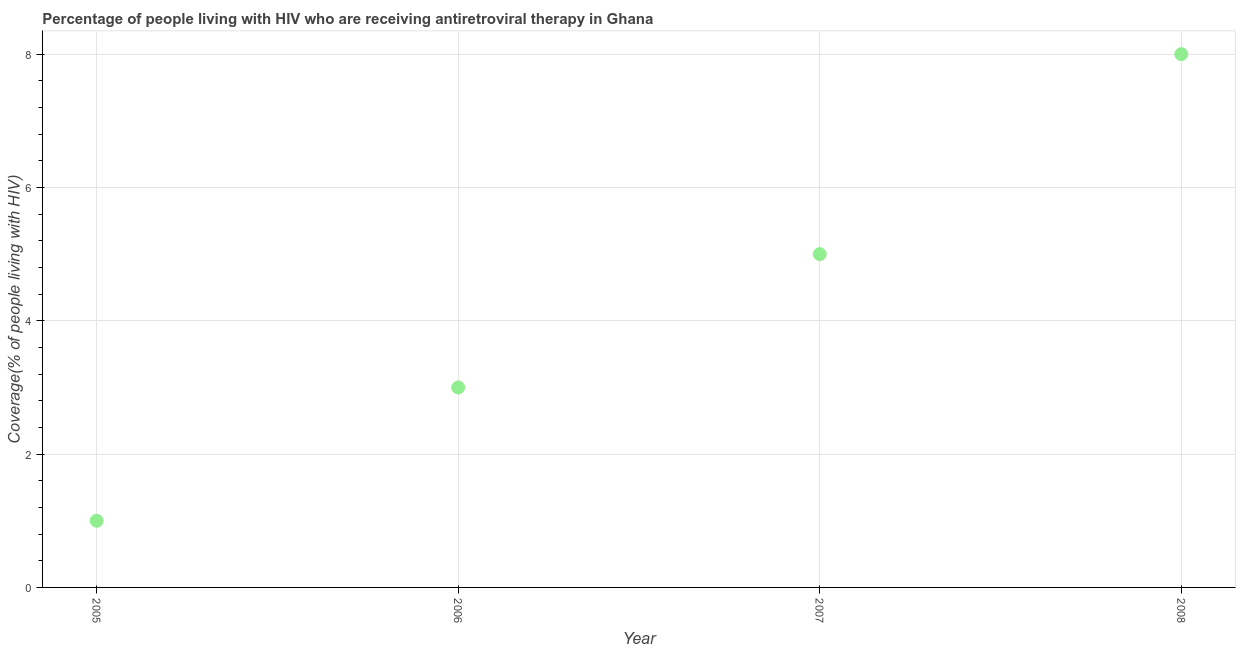What is the antiretroviral therapy coverage in 2007?
Offer a very short reply. 5. Across all years, what is the maximum antiretroviral therapy coverage?
Offer a very short reply. 8. Across all years, what is the minimum antiretroviral therapy coverage?
Your answer should be very brief. 1. In which year was the antiretroviral therapy coverage minimum?
Your response must be concise. 2005. What is the sum of the antiretroviral therapy coverage?
Offer a very short reply. 17. What is the difference between the antiretroviral therapy coverage in 2006 and 2007?
Your response must be concise. -2. What is the average antiretroviral therapy coverage per year?
Offer a very short reply. 4.25. In how many years, is the antiretroviral therapy coverage greater than 5.2 %?
Provide a succinct answer. 1. Is the difference between the antiretroviral therapy coverage in 2006 and 2007 greater than the difference between any two years?
Your answer should be very brief. No. Is the sum of the antiretroviral therapy coverage in 2005 and 2006 greater than the maximum antiretroviral therapy coverage across all years?
Give a very brief answer. No. What is the difference between the highest and the lowest antiretroviral therapy coverage?
Your answer should be very brief. 7. In how many years, is the antiretroviral therapy coverage greater than the average antiretroviral therapy coverage taken over all years?
Offer a very short reply. 2. Does the antiretroviral therapy coverage monotonically increase over the years?
Your response must be concise. Yes. How many years are there in the graph?
Give a very brief answer. 4. What is the difference between two consecutive major ticks on the Y-axis?
Ensure brevity in your answer.  2. Does the graph contain any zero values?
Offer a terse response. No. Does the graph contain grids?
Your answer should be compact. Yes. What is the title of the graph?
Offer a terse response. Percentage of people living with HIV who are receiving antiretroviral therapy in Ghana. What is the label or title of the Y-axis?
Give a very brief answer. Coverage(% of people living with HIV). What is the Coverage(% of people living with HIV) in 2006?
Provide a short and direct response. 3. What is the Coverage(% of people living with HIV) in 2008?
Provide a short and direct response. 8. What is the difference between the Coverage(% of people living with HIV) in 2005 and 2007?
Offer a very short reply. -4. What is the difference between the Coverage(% of people living with HIV) in 2006 and 2007?
Provide a short and direct response. -2. What is the difference between the Coverage(% of people living with HIV) in 2007 and 2008?
Offer a very short reply. -3. What is the ratio of the Coverage(% of people living with HIV) in 2005 to that in 2006?
Your answer should be very brief. 0.33. What is the ratio of the Coverage(% of people living with HIV) in 2005 to that in 2008?
Ensure brevity in your answer.  0.12. What is the ratio of the Coverage(% of people living with HIV) in 2006 to that in 2007?
Keep it short and to the point. 0.6. 